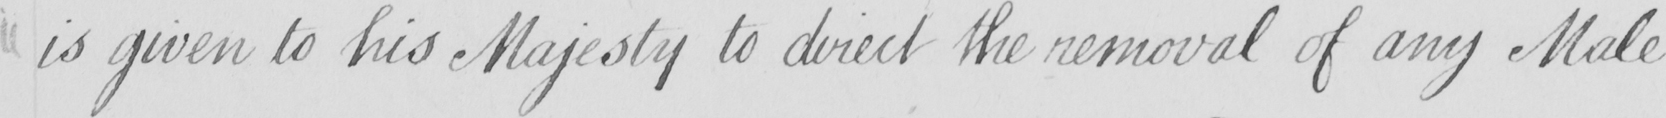Transcribe the text shown in this historical manuscript line. is given to his Majesty to direct the removal of any Male 